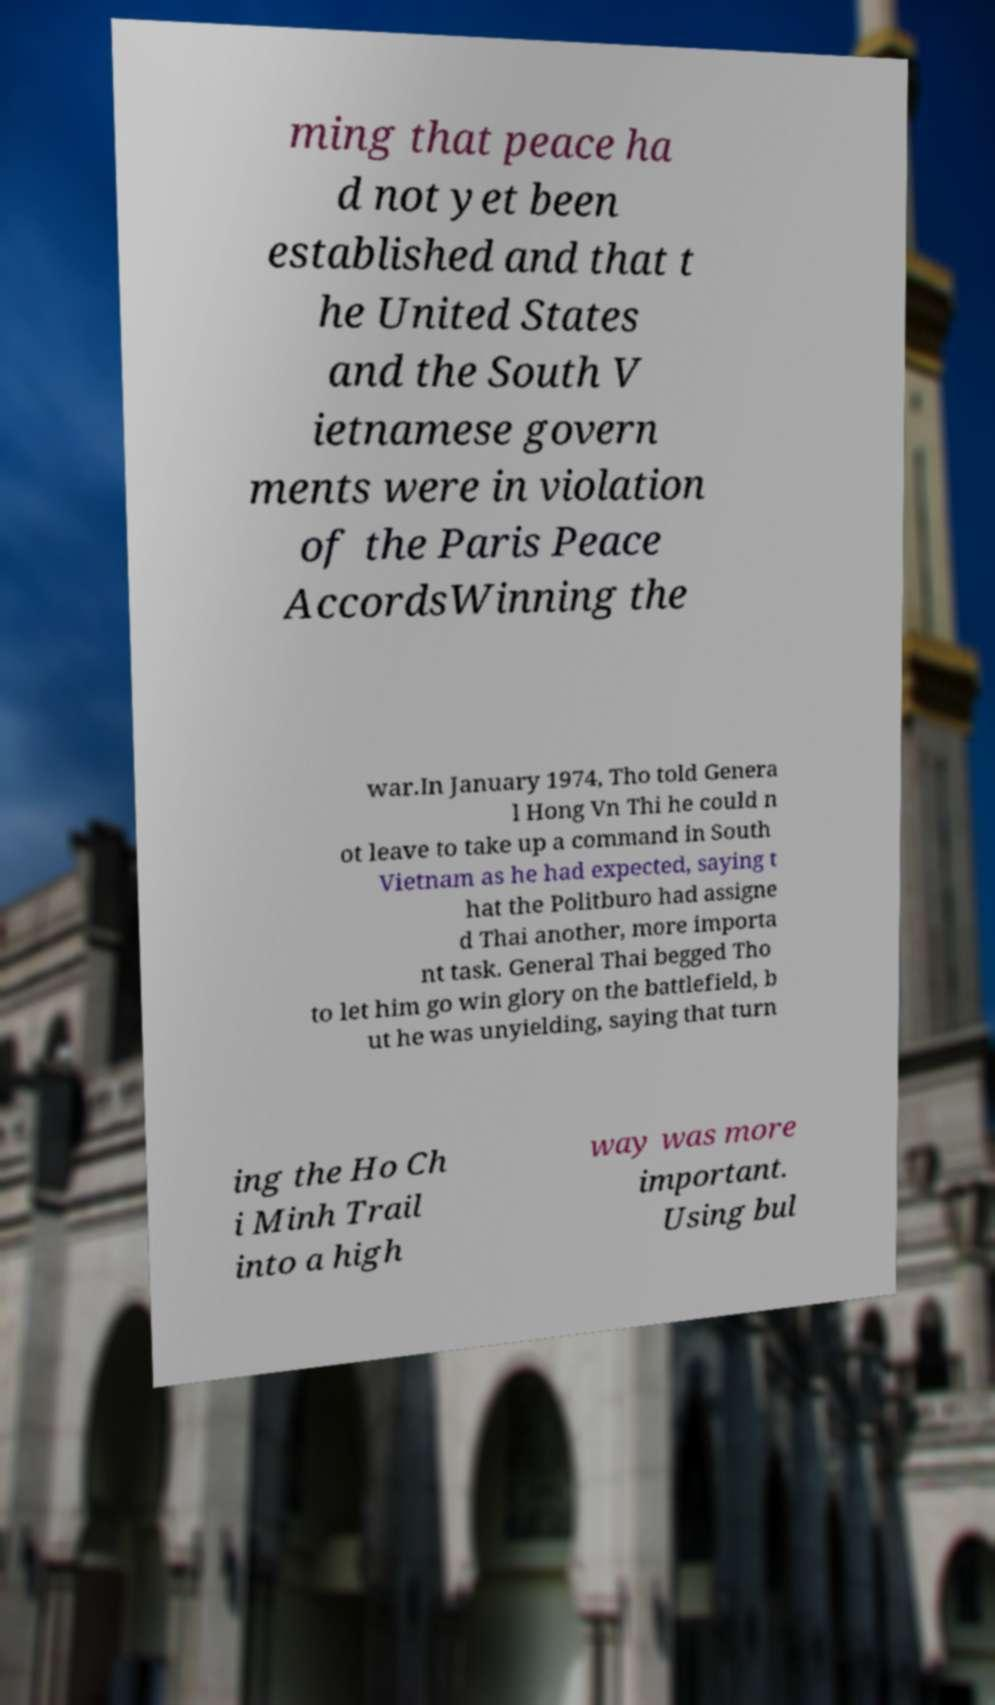Please identify and transcribe the text found in this image. ming that peace ha d not yet been established and that t he United States and the South V ietnamese govern ments were in violation of the Paris Peace AccordsWinning the war.In January 1974, Tho told Genera l Hong Vn Thi he could n ot leave to take up a command in South Vietnam as he had expected, saying t hat the Politburo had assigne d Thai another, more importa nt task. General Thai begged Tho to let him go win glory on the battlefield, b ut he was unyielding, saying that turn ing the Ho Ch i Minh Trail into a high way was more important. Using bul 